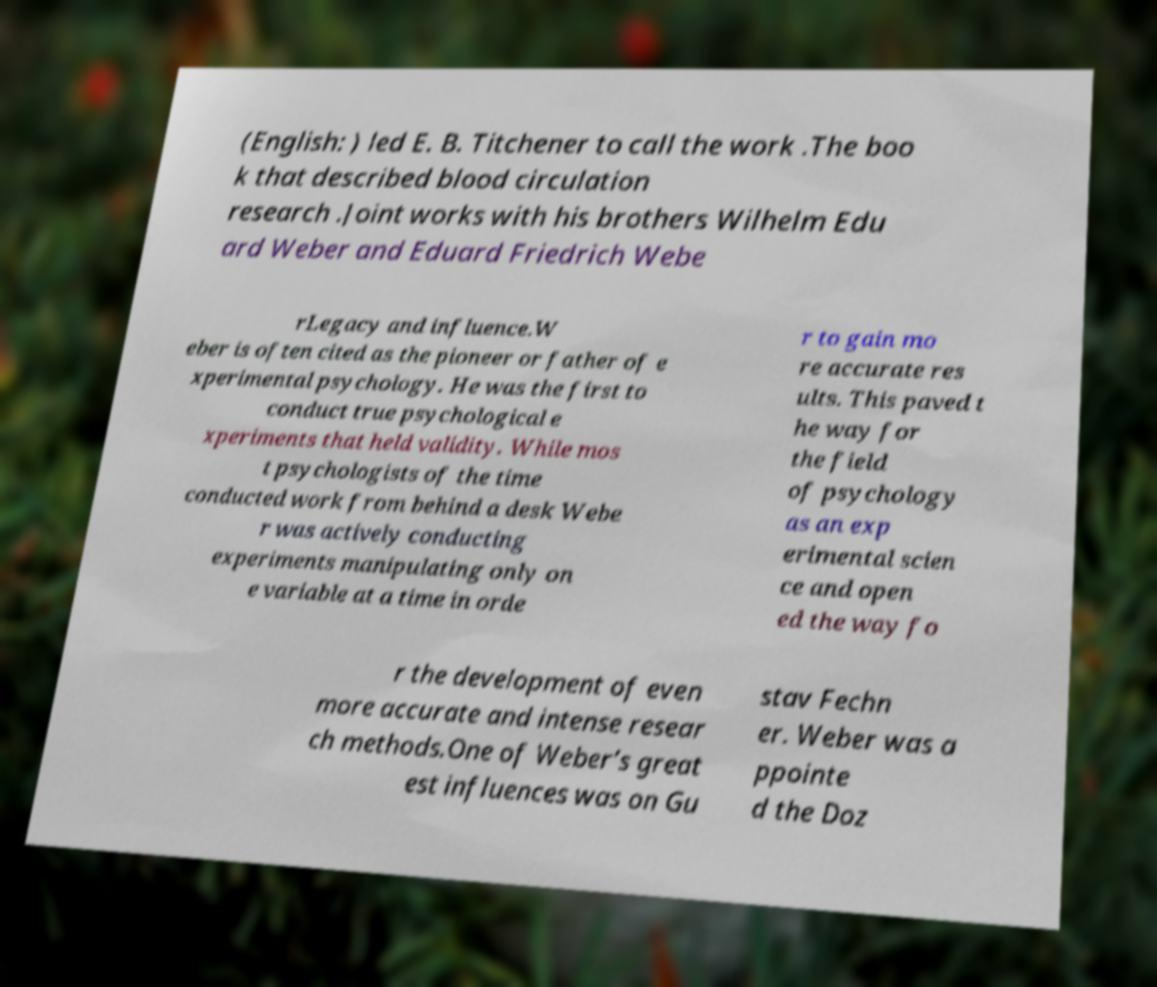Please identify and transcribe the text found in this image. (English: ) led E. B. Titchener to call the work .The boo k that described blood circulation research .Joint works with his brothers Wilhelm Edu ard Weber and Eduard Friedrich Webe rLegacy and influence.W eber is often cited as the pioneer or father of e xperimental psychology. He was the first to conduct true psychological e xperiments that held validity. While mos t psychologists of the time conducted work from behind a desk Webe r was actively conducting experiments manipulating only on e variable at a time in orde r to gain mo re accurate res ults. This paved t he way for the field of psychology as an exp erimental scien ce and open ed the way fo r the development of even more accurate and intense resear ch methods.One of Weber’s great est influences was on Gu stav Fechn er. Weber was a ppointe d the Doz 